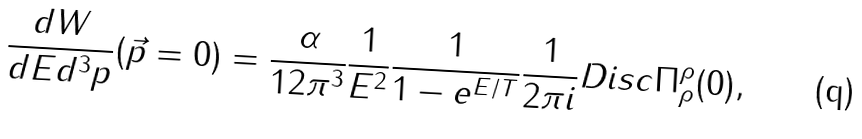<formula> <loc_0><loc_0><loc_500><loc_500>\frac { d W } { d E d ^ { 3 } p } ( \vec { p } = 0 ) = \frac { \alpha } { 1 2 \pi ^ { 3 } } \frac { 1 } { E ^ { 2 } } \frac { 1 } { 1 - e ^ { E / T } } \frac { 1 } { 2 \pi i } D i s c \Pi _ { \rho } ^ { \rho } ( 0 ) ,</formula> 